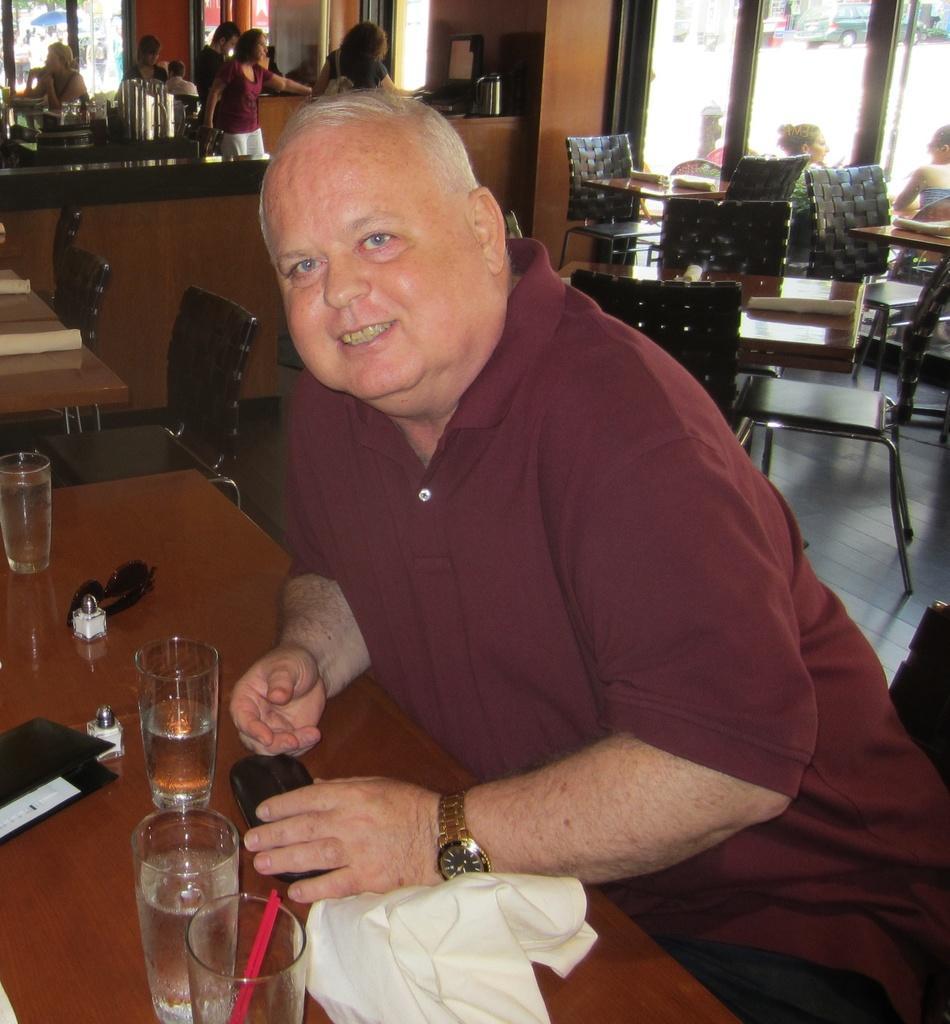Please provide a concise description of this image. In this image we can see a man sitting on the chair, and in front here is the table and glass and some objects on it, and here are the persons standing, and here is the glass door. 